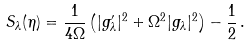Convert formula to latex. <formula><loc_0><loc_0><loc_500><loc_500>S _ { \lambda } ( \eta ) = \frac { 1 } { 4 \Omega } \left ( | g ^ { \prime } _ { \lambda } | ^ { 2 } + \Omega ^ { 2 } | g _ { \lambda } | ^ { 2 } \right ) - \frac { 1 } { 2 } \, .</formula> 